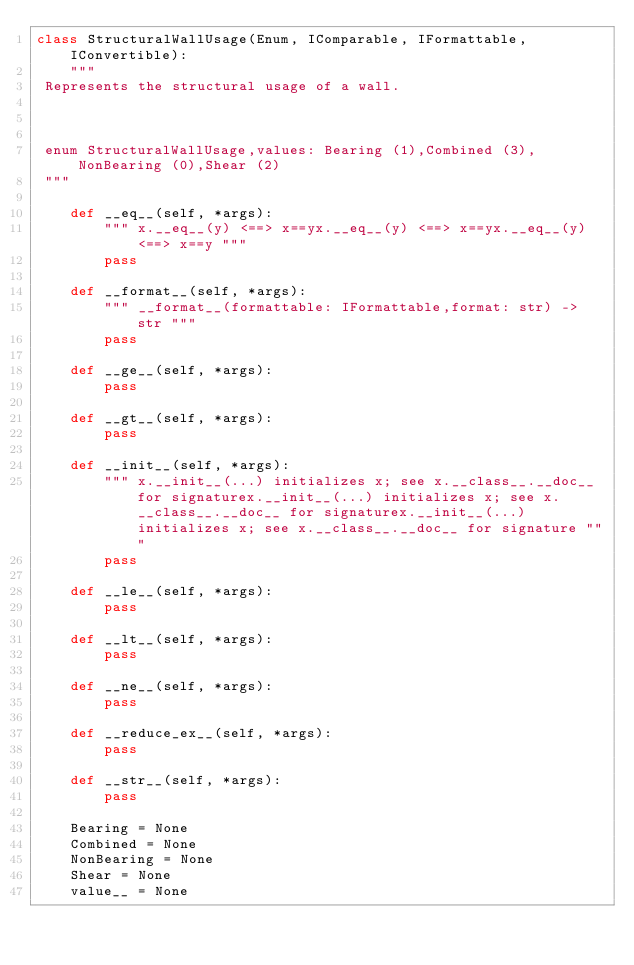Convert code to text. <code><loc_0><loc_0><loc_500><loc_500><_Python_>class StructuralWallUsage(Enum, IComparable, IFormattable, IConvertible):
    """
 Represents the structural usage of a wall.

 

 enum StructuralWallUsage,values: Bearing (1),Combined (3),NonBearing (0),Shear (2)
 """

    def __eq__(self, *args):
        """ x.__eq__(y) <==> x==yx.__eq__(y) <==> x==yx.__eq__(y) <==> x==y """
        pass

    def __format__(self, *args):
        """ __format__(formattable: IFormattable,format: str) -> str """
        pass

    def __ge__(self, *args):
        pass

    def __gt__(self, *args):
        pass

    def __init__(self, *args):
        """ x.__init__(...) initializes x; see x.__class__.__doc__ for signaturex.__init__(...) initializes x; see x.__class__.__doc__ for signaturex.__init__(...) initializes x; see x.__class__.__doc__ for signature """
        pass

    def __le__(self, *args):
        pass

    def __lt__(self, *args):
        pass

    def __ne__(self, *args):
        pass

    def __reduce_ex__(self, *args):
        pass

    def __str__(self, *args):
        pass

    Bearing = None
    Combined = None
    NonBearing = None
    Shear = None
    value__ = None
</code> 